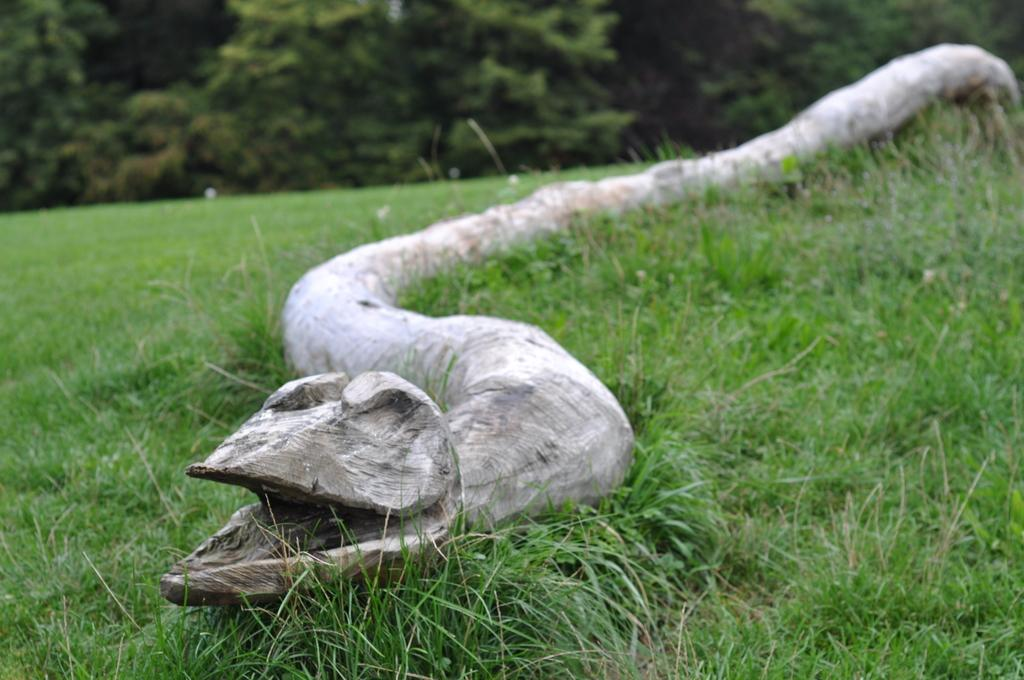What type of vegetation can be seen in the image? There are trees in the image. What material is the wooden object made of? The wooden object in the image is made of wood. What type of ground cover is visible at the bottom of the image? Grass is visible at the bottom of the image. What type of jeans is the mother wearing in the image? There is no mother or jeans present in the image; it features in the image include trees, a wooden object, and grass. 